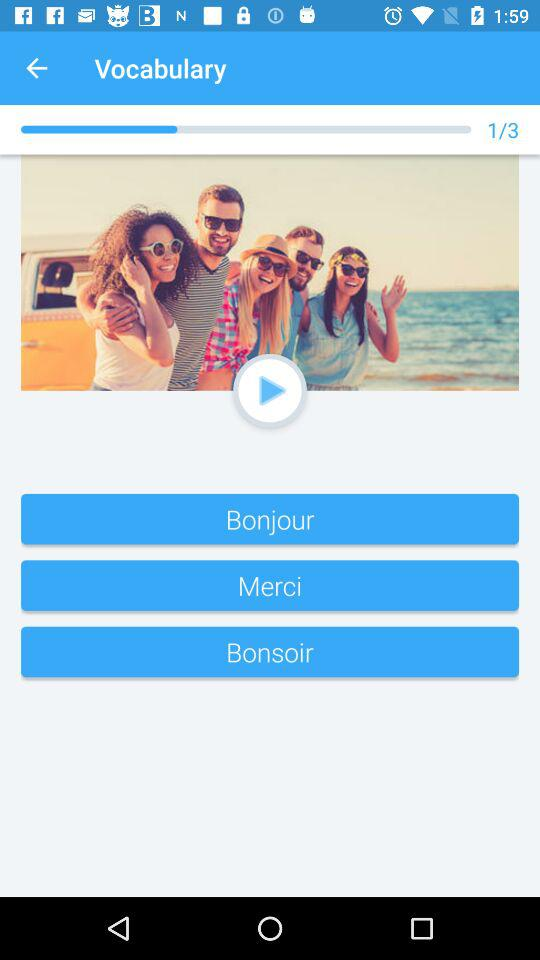At which question am I? You are at the first question. 